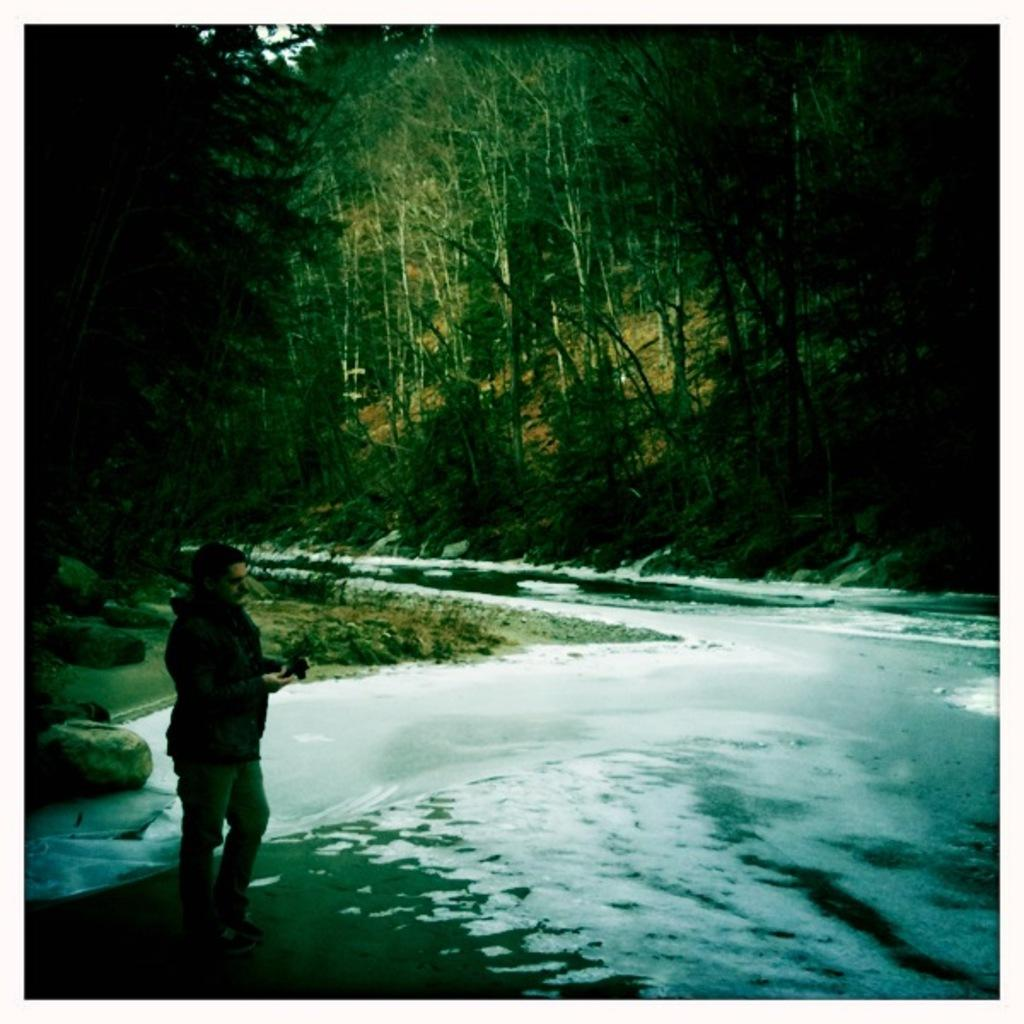What is the main feature of the image? There is a road in the image. What can be seen surrounding the road? The road is situated between trees. What is a person doing in the image? There is a man standing on the road in the image. What type of clothing is the man wearing? The man is wearing a jacket. What color is the crib in the image? There is no crib present in the image. 